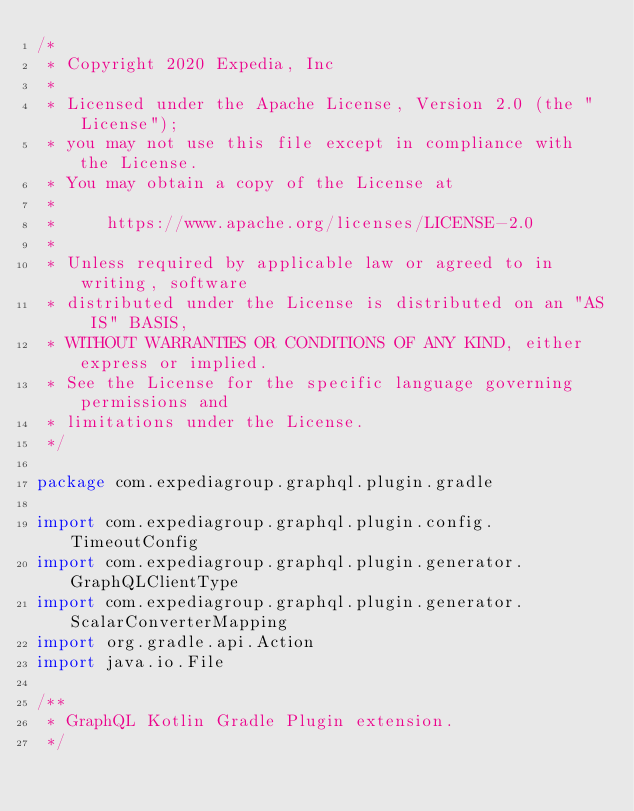Convert code to text. <code><loc_0><loc_0><loc_500><loc_500><_Kotlin_>/*
 * Copyright 2020 Expedia, Inc
 *
 * Licensed under the Apache License, Version 2.0 (the "License");
 * you may not use this file except in compliance with the License.
 * You may obtain a copy of the License at
 *
 *     https://www.apache.org/licenses/LICENSE-2.0
 *
 * Unless required by applicable law or agreed to in writing, software
 * distributed under the License is distributed on an "AS IS" BASIS,
 * WITHOUT WARRANTIES OR CONDITIONS OF ANY KIND, either express or implied.
 * See the License for the specific language governing permissions and
 * limitations under the License.
 */

package com.expediagroup.graphql.plugin.gradle

import com.expediagroup.graphql.plugin.config.TimeoutConfig
import com.expediagroup.graphql.plugin.generator.GraphQLClientType
import com.expediagroup.graphql.plugin.generator.ScalarConverterMapping
import org.gradle.api.Action
import java.io.File

/**
 * GraphQL Kotlin Gradle Plugin extension.
 */</code> 